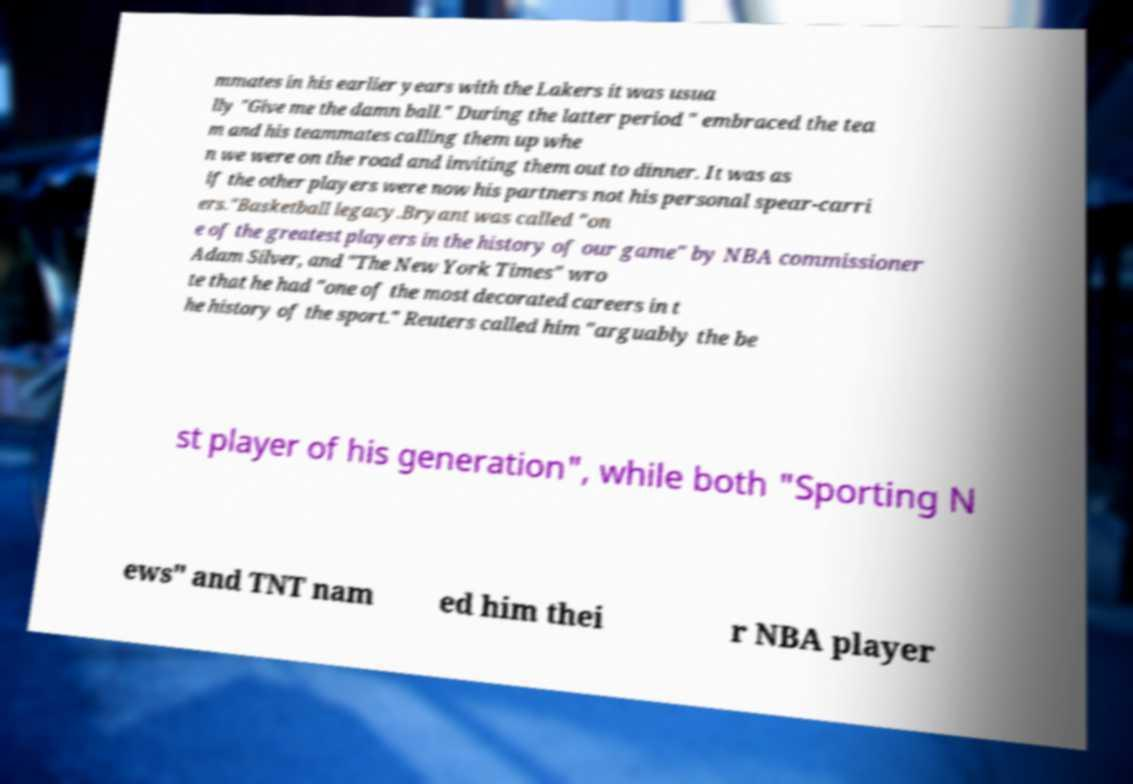Can you accurately transcribe the text from the provided image for me? mmates in his earlier years with the Lakers it was usua lly "Give me the damn ball." During the latter period " embraced the tea m and his teammates calling them up whe n we were on the road and inviting them out to dinner. It was as if the other players were now his partners not his personal spear-carri ers."Basketball legacy.Bryant was called "on e of the greatest players in the history of our game" by NBA commissioner Adam Silver, and "The New York Times" wro te that he had "one of the most decorated careers in t he history of the sport." Reuters called him "arguably the be st player of his generation", while both "Sporting N ews" and TNT nam ed him thei r NBA player 